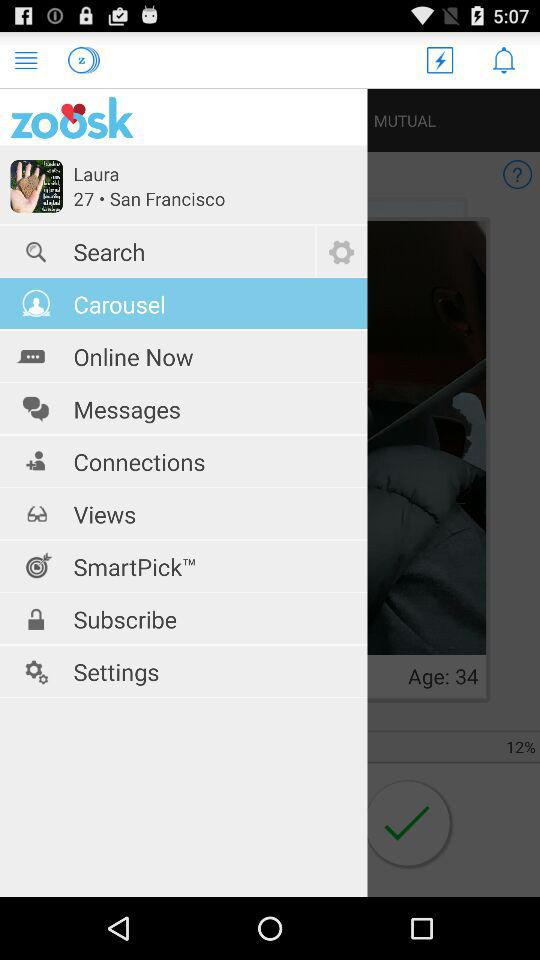What is the location? The location is San Francisco. 